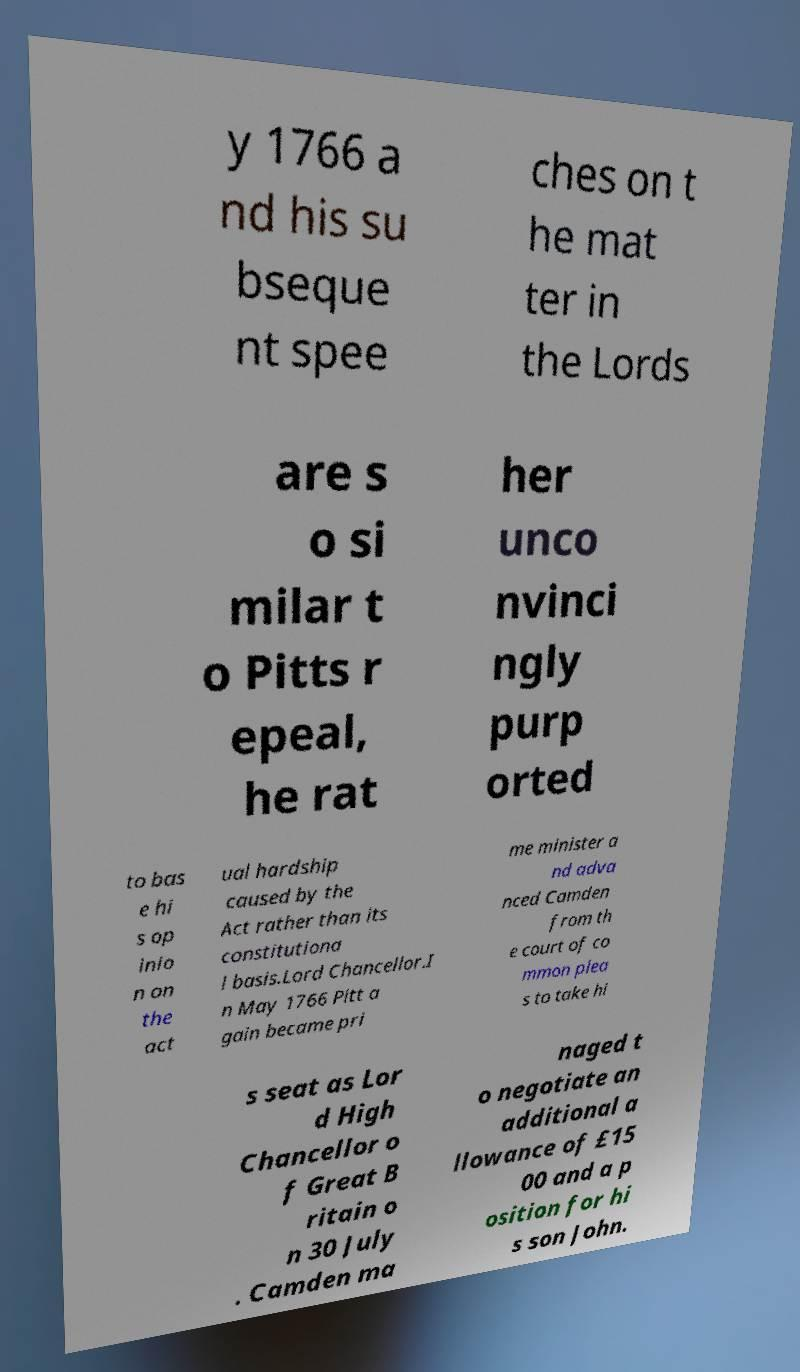There's text embedded in this image that I need extracted. Can you transcribe it verbatim? y 1766 a nd his su bseque nt spee ches on t he mat ter in the Lords are s o si milar t o Pitts r epeal, he rat her unco nvinci ngly purp orted to bas e hi s op inio n on the act ual hardship caused by the Act rather than its constitutiona l basis.Lord Chancellor.I n May 1766 Pitt a gain became pri me minister a nd adva nced Camden from th e court of co mmon plea s to take hi s seat as Lor d High Chancellor o f Great B ritain o n 30 July . Camden ma naged t o negotiate an additional a llowance of £15 00 and a p osition for hi s son John. 